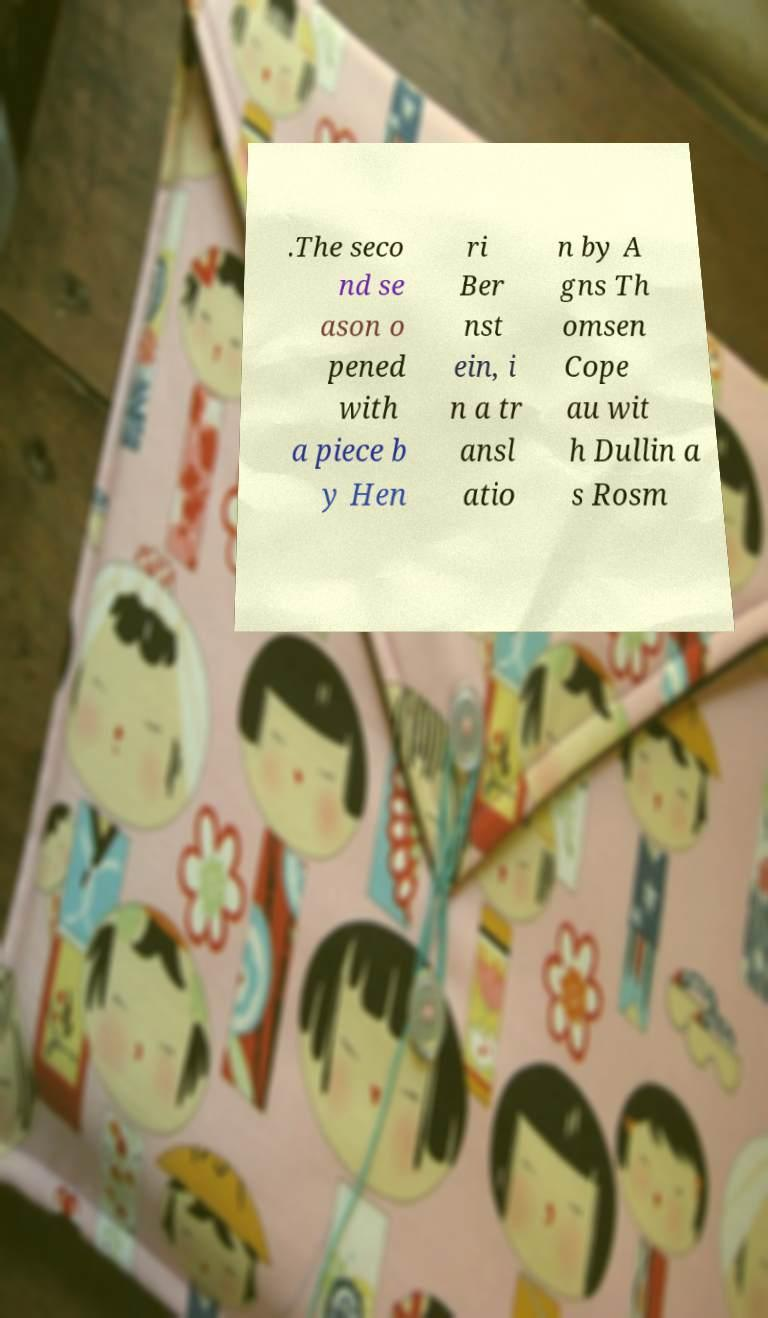What messages or text are displayed in this image? I need them in a readable, typed format. .The seco nd se ason o pened with a piece b y Hen ri Ber nst ein, i n a tr ansl atio n by A gns Th omsen Cope au wit h Dullin a s Rosm 